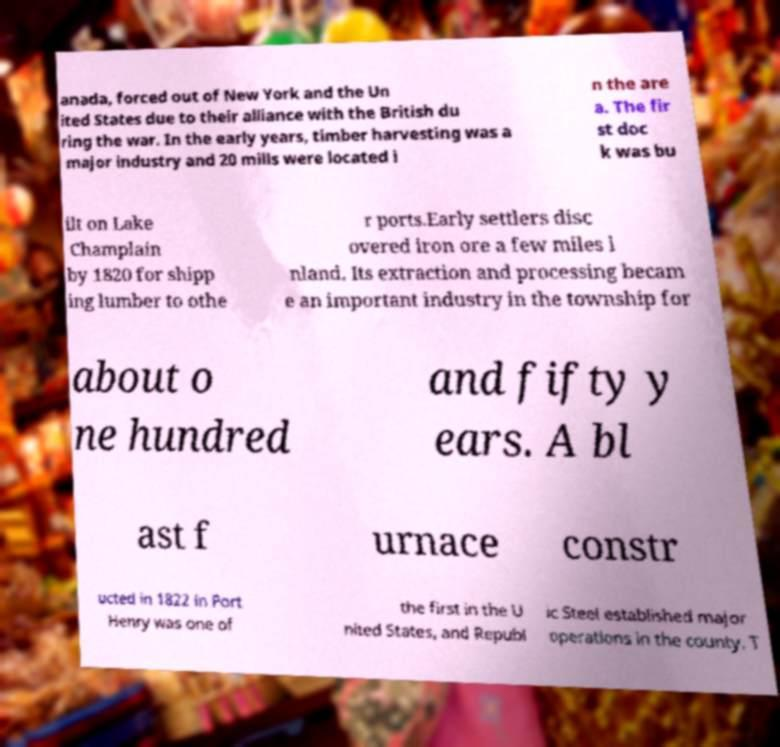Could you assist in decoding the text presented in this image and type it out clearly? anada, forced out of New York and the Un ited States due to their alliance with the British du ring the war. In the early years, timber harvesting was a major industry and 20 mills were located i n the are a. The fir st doc k was bu ilt on Lake Champlain by 1820 for shipp ing lumber to othe r ports.Early settlers disc overed iron ore a few miles i nland. Its extraction and processing becam e an important industry in the township for about o ne hundred and fifty y ears. A bl ast f urnace constr ucted in 1822 in Port Henry was one of the first in the U nited States, and Republ ic Steel established major operations in the county. T 